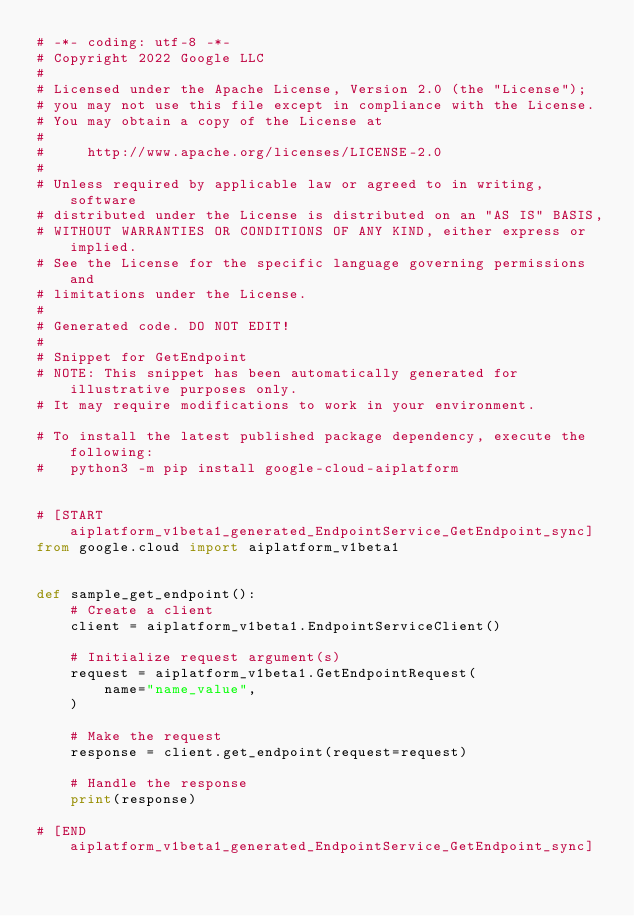<code> <loc_0><loc_0><loc_500><loc_500><_Python_># -*- coding: utf-8 -*-
# Copyright 2022 Google LLC
#
# Licensed under the Apache License, Version 2.0 (the "License");
# you may not use this file except in compliance with the License.
# You may obtain a copy of the License at
#
#     http://www.apache.org/licenses/LICENSE-2.0
#
# Unless required by applicable law or agreed to in writing, software
# distributed under the License is distributed on an "AS IS" BASIS,
# WITHOUT WARRANTIES OR CONDITIONS OF ANY KIND, either express or implied.
# See the License for the specific language governing permissions and
# limitations under the License.
#
# Generated code. DO NOT EDIT!
#
# Snippet for GetEndpoint
# NOTE: This snippet has been automatically generated for illustrative purposes only.
# It may require modifications to work in your environment.

# To install the latest published package dependency, execute the following:
#   python3 -m pip install google-cloud-aiplatform


# [START aiplatform_v1beta1_generated_EndpointService_GetEndpoint_sync]
from google.cloud import aiplatform_v1beta1


def sample_get_endpoint():
    # Create a client
    client = aiplatform_v1beta1.EndpointServiceClient()

    # Initialize request argument(s)
    request = aiplatform_v1beta1.GetEndpointRequest(
        name="name_value",
    )

    # Make the request
    response = client.get_endpoint(request=request)

    # Handle the response
    print(response)

# [END aiplatform_v1beta1_generated_EndpointService_GetEndpoint_sync]
</code> 